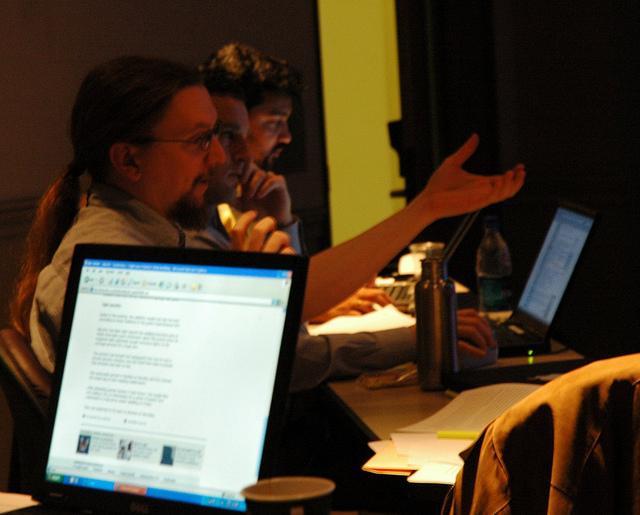What is the man holding in his hand?
Short answer required. Nothing. What color are his glasses?
Answer briefly. Black. Are they sitting at a desk?
Keep it brief. Yes. How many laptops are there?
Keep it brief. 3. 